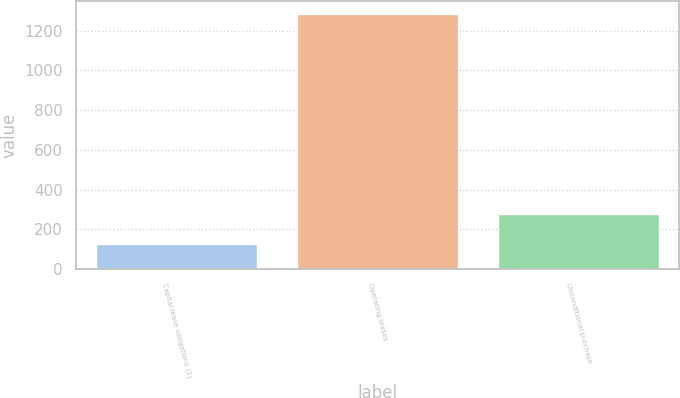Convert chart to OTSL. <chart><loc_0><loc_0><loc_500><loc_500><bar_chart><fcel>Capital lease obligations (2)<fcel>Operating leases<fcel>Unconditional purchase<nl><fcel>125<fcel>1285<fcel>275<nl></chart> 